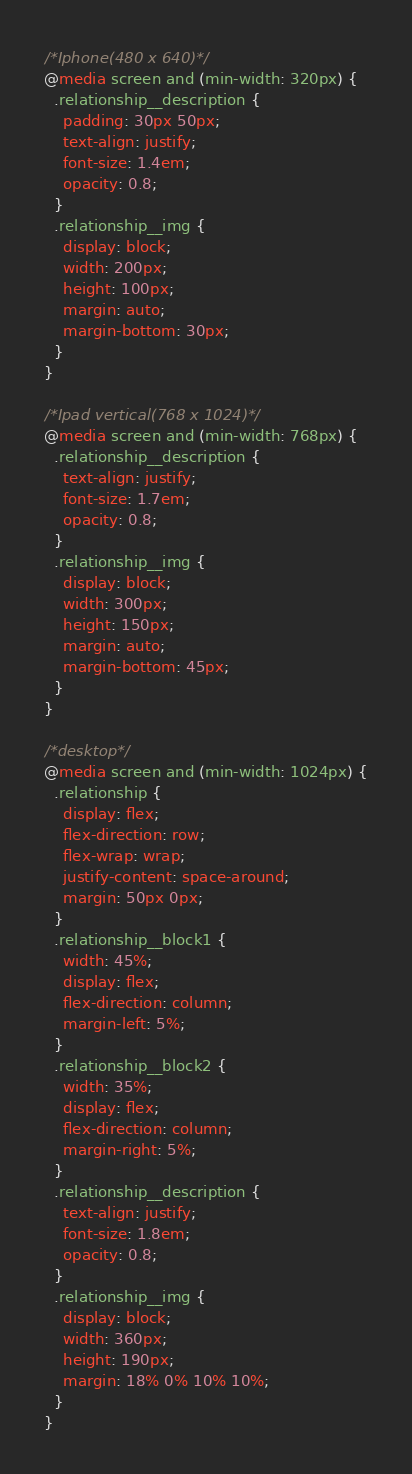Convert code to text. <code><loc_0><loc_0><loc_500><loc_500><_CSS_>/*Iphone(480 x 640)*/
@media screen and (min-width: 320px) {
  .relationship__description {
    padding: 30px 50px;
    text-align: justify;
    font-size: 1.4em;
    opacity: 0.8;
  }
  .relationship__img {
    display: block;
    width: 200px;
    height: 100px;
    margin: auto;
    margin-bottom: 30px;
  }
}

/*Ipad vertical(768 x 1024)*/
@media screen and (min-width: 768px) {
  .relationship__description {
    text-align: justify;
    font-size: 1.7em;
    opacity: 0.8;
  }
  .relationship__img {
    display: block;
    width: 300px;
    height: 150px;
    margin: auto;
    margin-bottom: 45px;
  }
}

/*desktop*/
@media screen and (min-width: 1024px) {
  .relationship {
    display: flex;
    flex-direction: row;
    flex-wrap: wrap;
    justify-content: space-around;
    margin: 50px 0px;
  }
  .relationship__block1 {
    width: 45%;
    display: flex;
    flex-direction: column;
    margin-left: 5%;
  }
  .relationship__block2 {
    width: 35%;
    display: flex;
    flex-direction: column;
    margin-right: 5%;
  }
  .relationship__description {
    text-align: justify;
    font-size: 1.8em;
    opacity: 0.8;
  }
  .relationship__img {
    display: block;
    width: 360px;
    height: 190px;
    margin: 18% 0% 10% 10%;
  }
}
</code> 